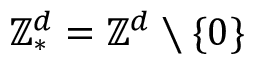<formula> <loc_0><loc_0><loc_500><loc_500>{ \mathbb { Z } ^ { d } } _ { * } = { \mathbb { Z } ^ { d } } \ \{ 0 \}</formula> 